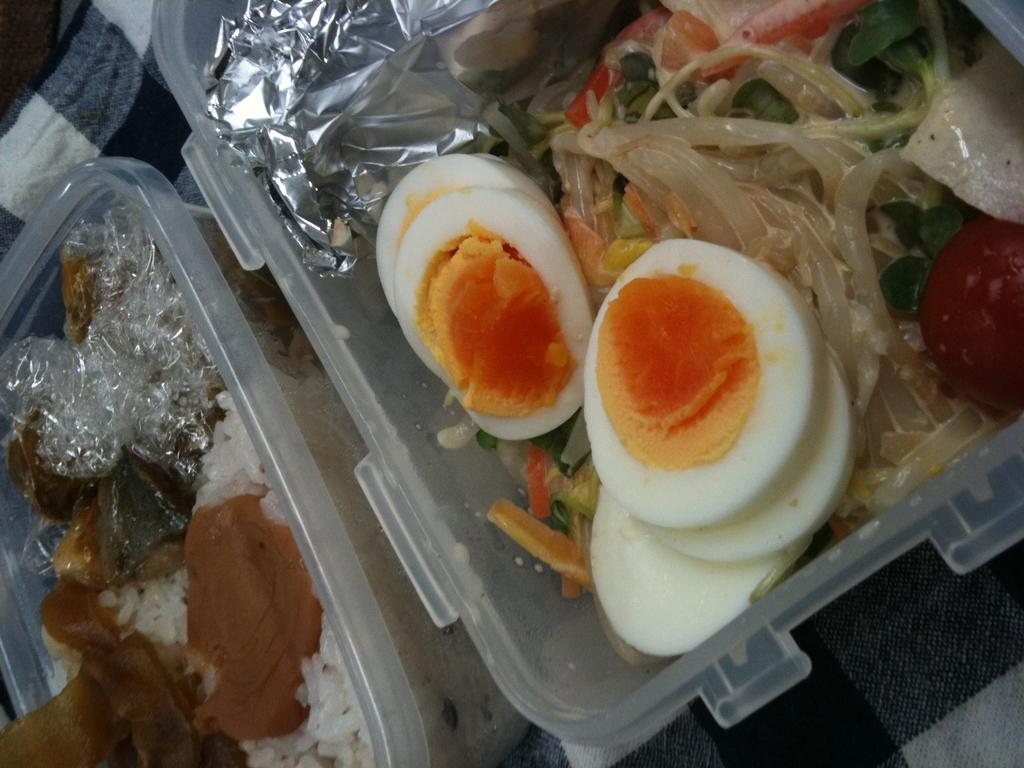What type of food is present in the image? There are egg pieces in the image, along with other food items. How are the food items contained in the image? The food items are in a plastic box. What type of liquid can be seen in the image? There is no liquid present in the image; it only contains egg pieces and other food items in a plastic box. 